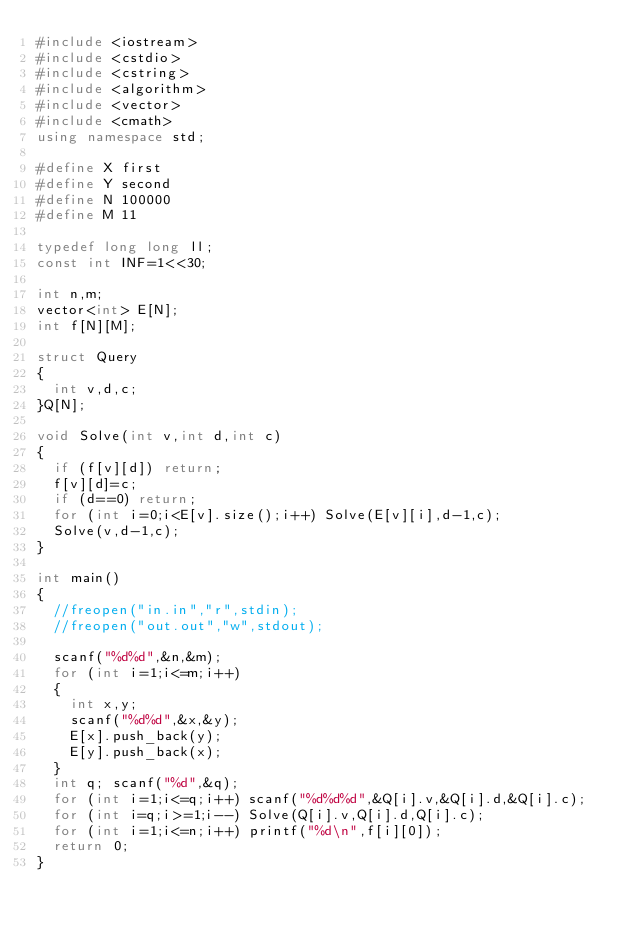Convert code to text. <code><loc_0><loc_0><loc_500><loc_500><_C++_>#include <iostream>
#include <cstdio>
#include <cstring>
#include <algorithm>
#include <vector>
#include <cmath>
using namespace std;

#define X first
#define Y second
#define N 100000
#define M 11

typedef long long ll;
const int INF=1<<30;

int n,m;
vector<int> E[N];
int f[N][M];

struct Query
{
	int v,d,c;
}Q[N];

void Solve(int v,int d,int c)
{
	if (f[v][d]) return;
	f[v][d]=c;
	if (d==0) return;
	for (int i=0;i<E[v].size();i++) Solve(E[v][i],d-1,c);
	Solve(v,d-1,c);
}

int main()
{
	//freopen("in.in","r",stdin);
	//freopen("out.out","w",stdout);
	
	scanf("%d%d",&n,&m);
	for (int i=1;i<=m;i++)
	{
		int x,y;
		scanf("%d%d",&x,&y);
		E[x].push_back(y);
		E[y].push_back(x);
	}
	int q; scanf("%d",&q);
	for (int i=1;i<=q;i++) scanf("%d%d%d",&Q[i].v,&Q[i].d,&Q[i].c);
	for (int i=q;i>=1;i--) Solve(Q[i].v,Q[i].d,Q[i].c);
	for (int i=1;i<=n;i++) printf("%d\n",f[i][0]);
	return 0;
}</code> 